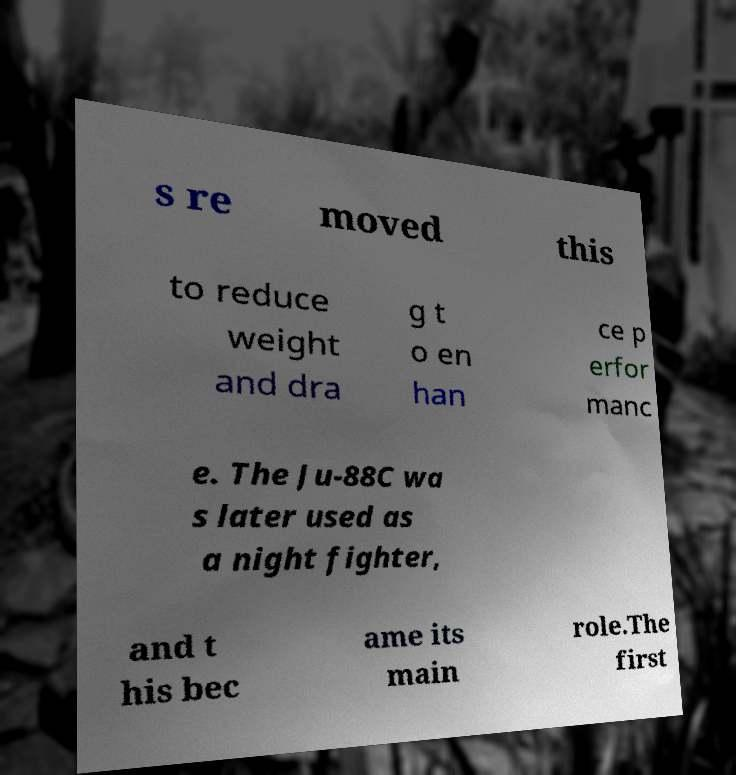Could you extract and type out the text from this image? s re moved this to reduce weight and dra g t o en han ce p erfor manc e. The Ju-88C wa s later used as a night fighter, and t his bec ame its main role.The first 